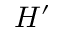Convert formula to latex. <formula><loc_0><loc_0><loc_500><loc_500>H ^ { \prime }</formula> 